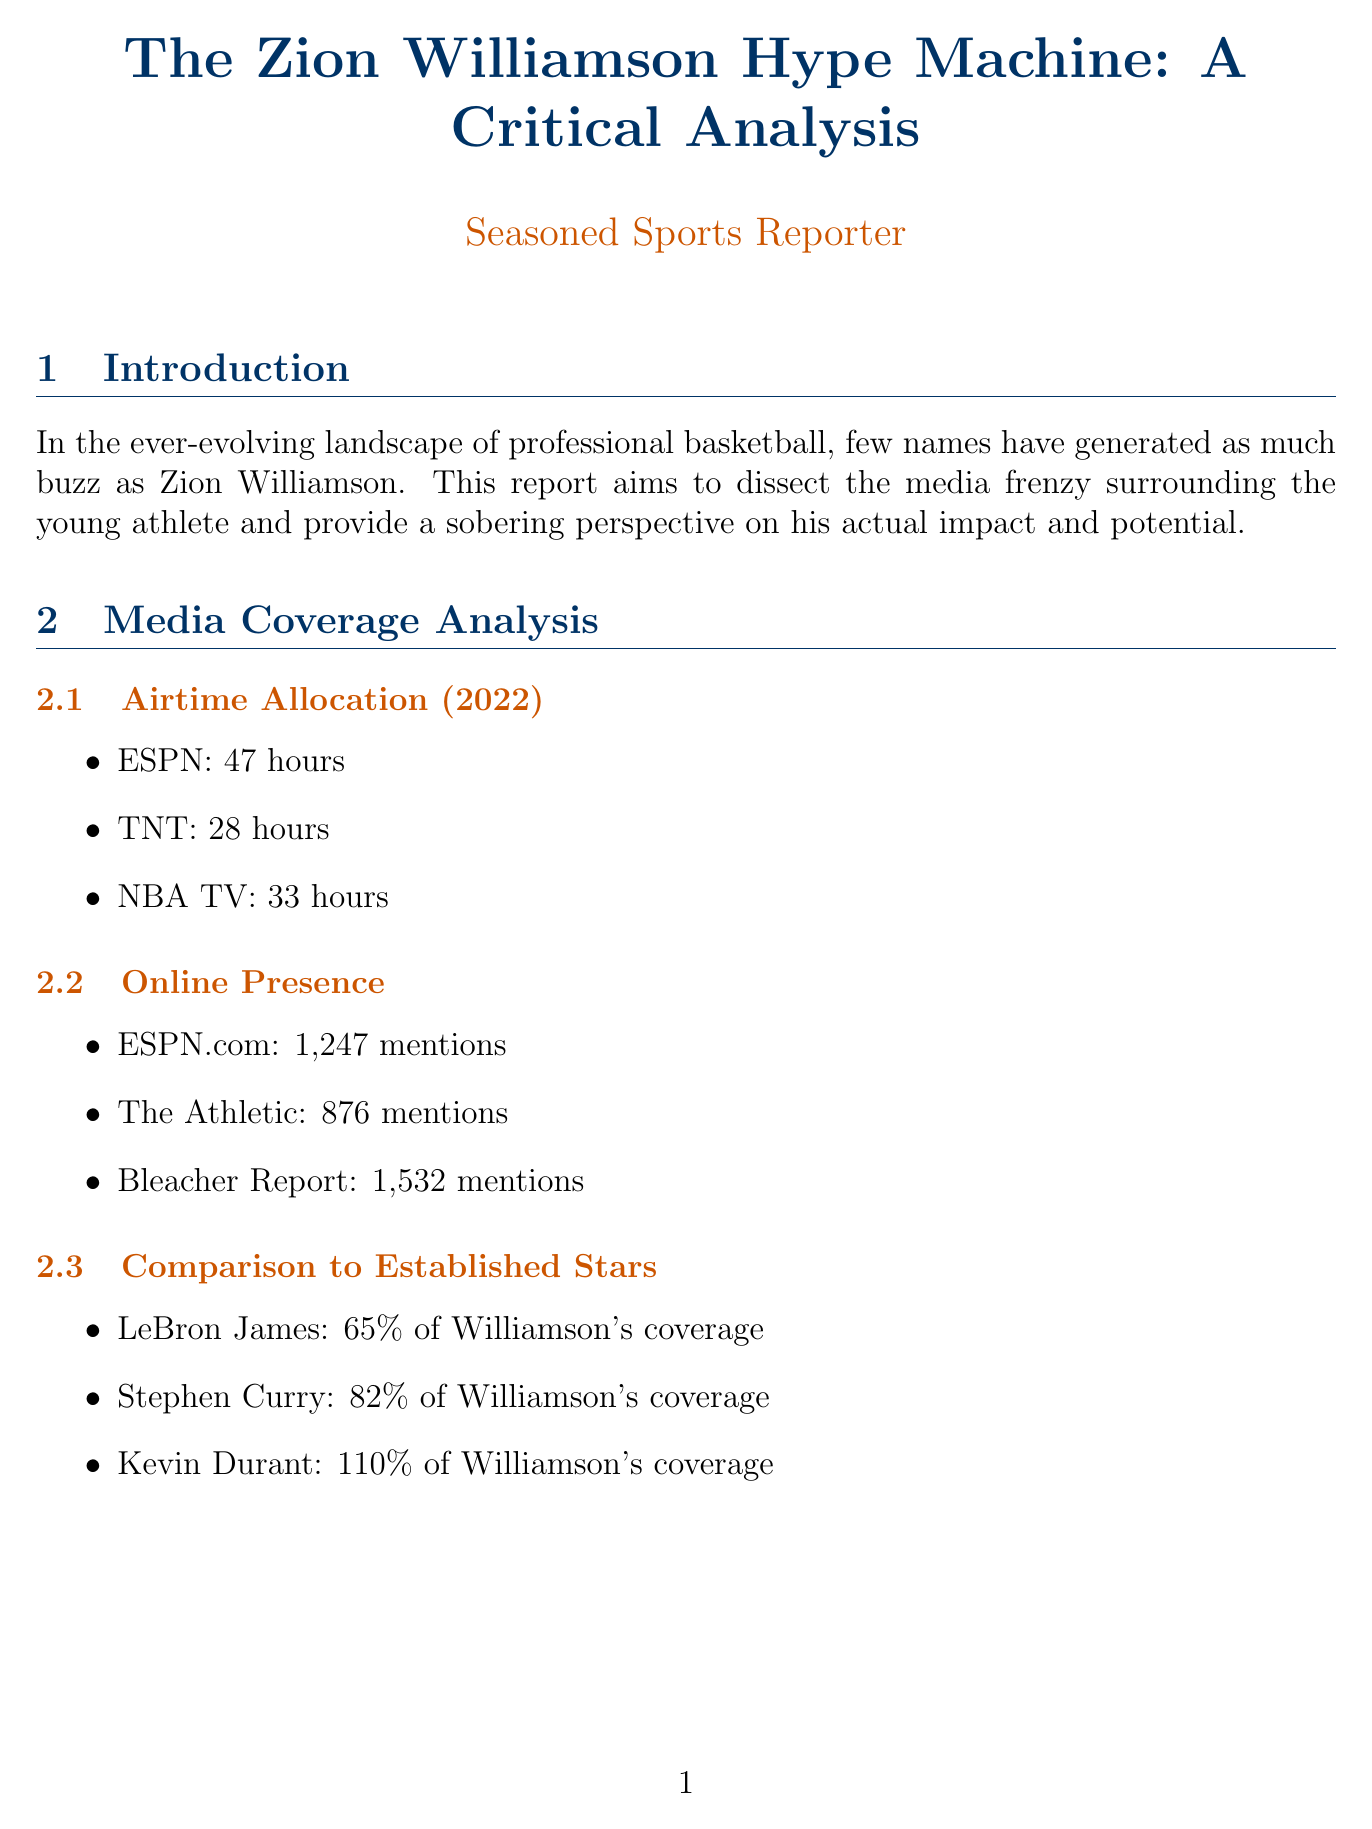what is Zion Williamson's age? The document states that Zion Williamson is currently 22 years old.
Answer: 22 how many games did Zion play in the 2022 season? The document specifies that Zion Williamson played 29 games in the 2022 season.
Answer: 29 what is the field goal percentage of Zion Williamson for the 2022 season? The field goal percentage mentioned in the document for Zion Williamson is 58.8%.
Answer: 58.8% who wrote the headline "Zion's Potential: The Next LeBron?" The document indicates that the outlet ESPN wrote this headline.
Answer: ESPN what percentage of positive fan sentiment was recorded? According to the document, 62% of fan sentiment was positive.
Answer: 62% compare Zion Williamson's media coverage to that of LeBron James. The document states that Williamson received 65% of the coverage compared to LeBron James.
Answer: 65% how many article mentions did Bleacher Report have for Zion Williamson in 2022? The document lists 1,532 mentions for Bleacher Report regarding Zion Williamson.
Answer: 1,532 which brand has the highest sponsorship deal value for Zion Williamson? The document shows that Jordan has the highest sponsorship deal value at $75 million.
Answer: $75 million what is the engagement rate of Zion Williamson on social media? The document reports that Zion Williamson has an engagement rate of 3.2%.
Answer: 3.2% 